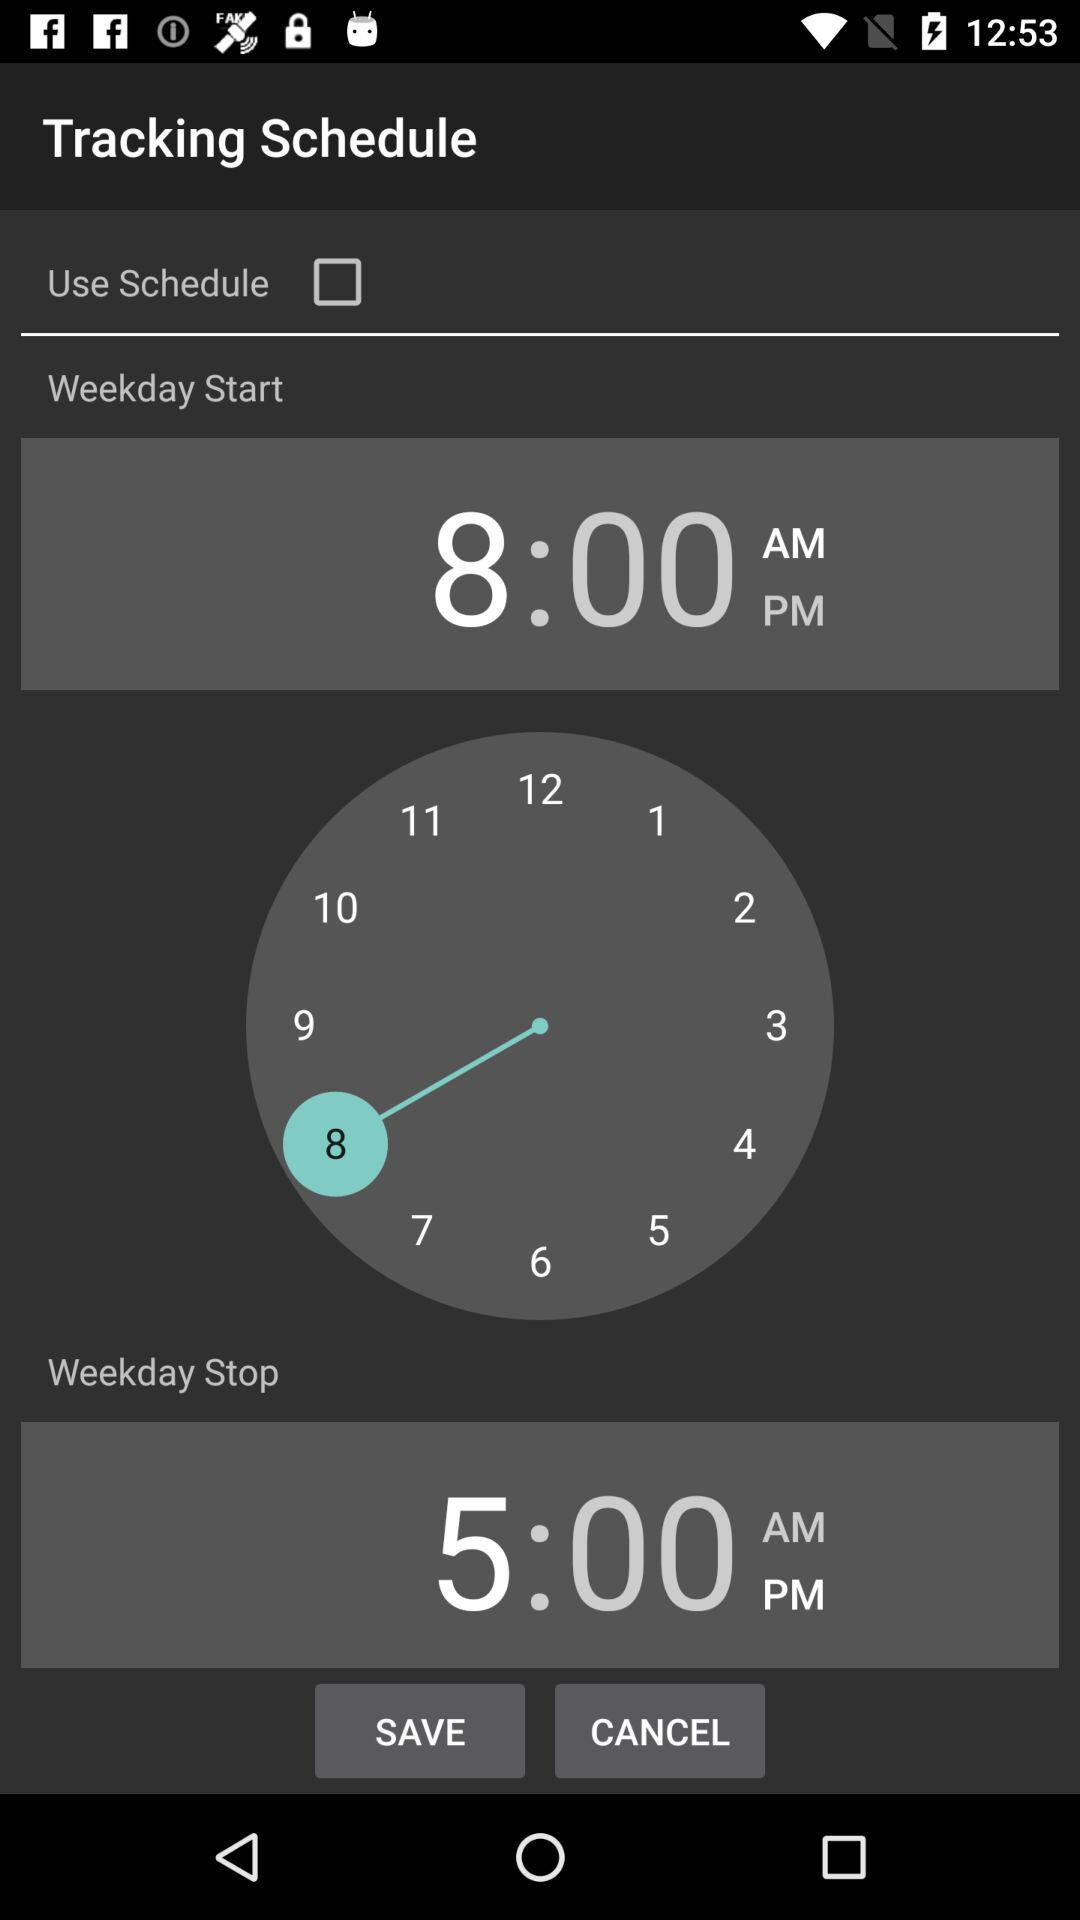When does the weekday stop? The weekday stops at 5:00 PM. 